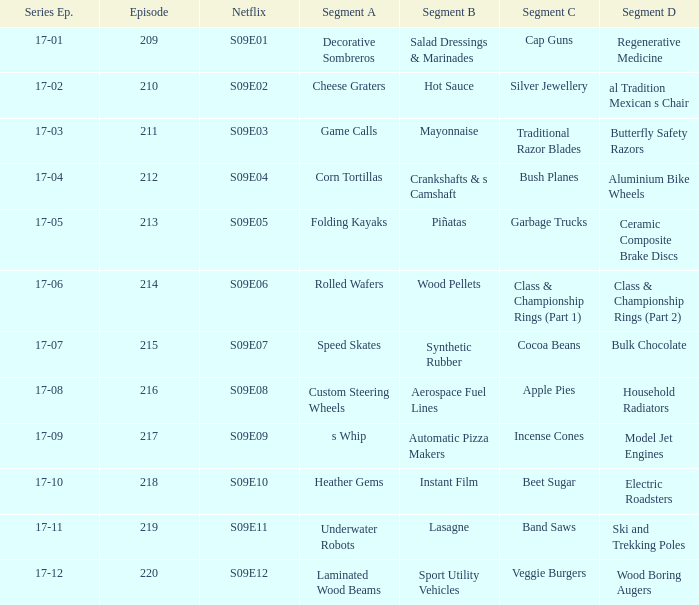Are rolled wafers in many episodes 17-06. 